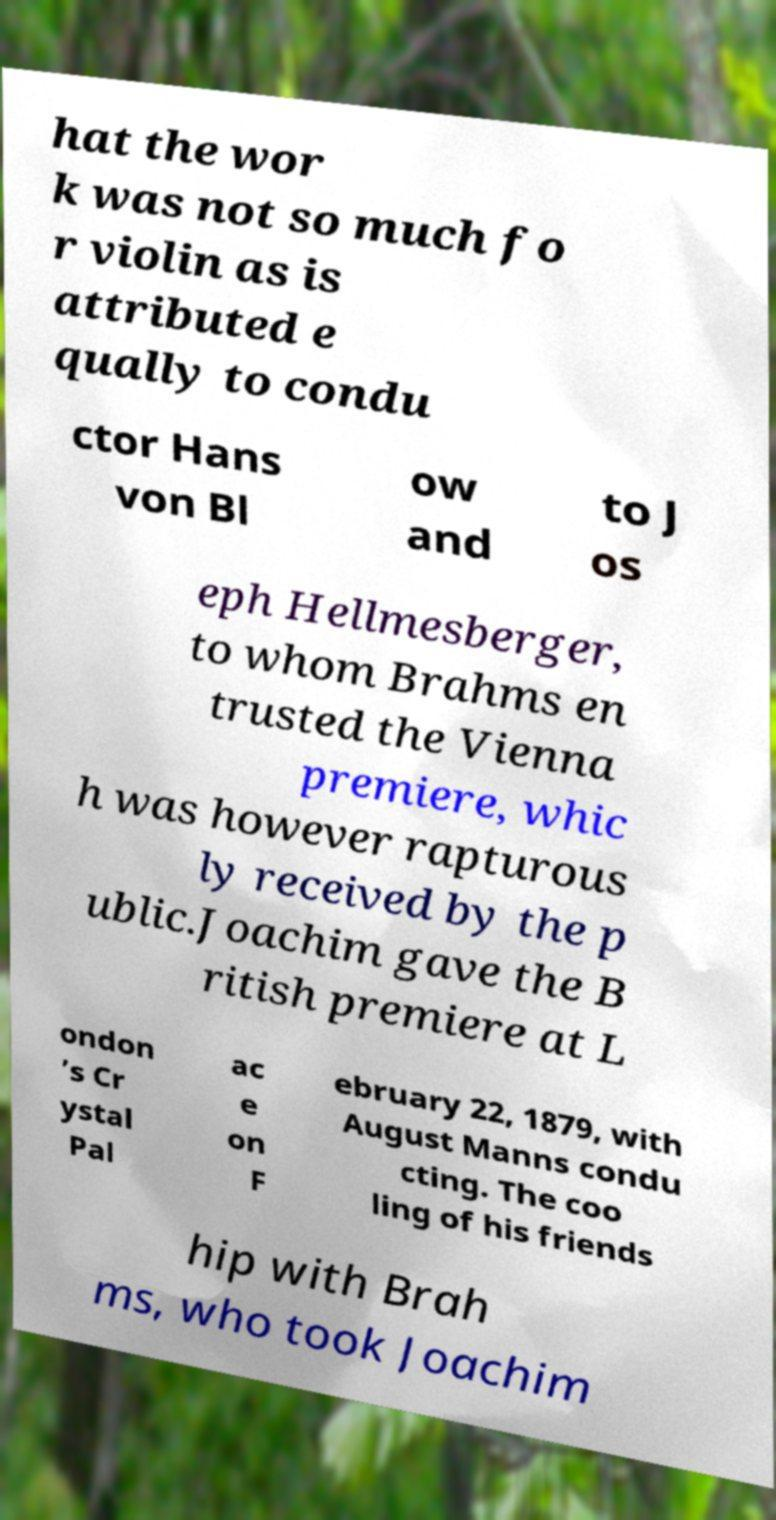Can you accurately transcribe the text from the provided image for me? hat the wor k was not so much fo r violin as is attributed e qually to condu ctor Hans von Bl ow and to J os eph Hellmesberger, to whom Brahms en trusted the Vienna premiere, whic h was however rapturous ly received by the p ublic.Joachim gave the B ritish premiere at L ondon ’s Cr ystal Pal ac e on F ebruary 22, 1879, with August Manns condu cting. The coo ling of his friends hip with Brah ms, who took Joachim 